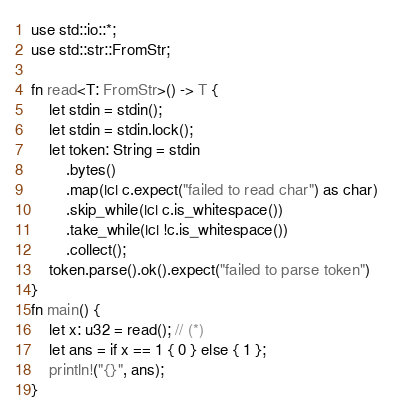Convert code to text. <code><loc_0><loc_0><loc_500><loc_500><_Rust_>use std::io::*;
use std::str::FromStr;

fn read<T: FromStr>() -> T {
    let stdin = stdin();
    let stdin = stdin.lock();
    let token: String = stdin
        .bytes()
        .map(|c| c.expect("failed to read char") as char)
        .skip_while(|c| c.is_whitespace())
        .take_while(|c| !c.is_whitespace())
        .collect();
    token.parse().ok().expect("failed to parse token")
}
fn main() {
    let x: u32 = read(); // (*)
    let ans = if x == 1 { 0 } else { 1 };
    println!("{}", ans);
}
</code> 